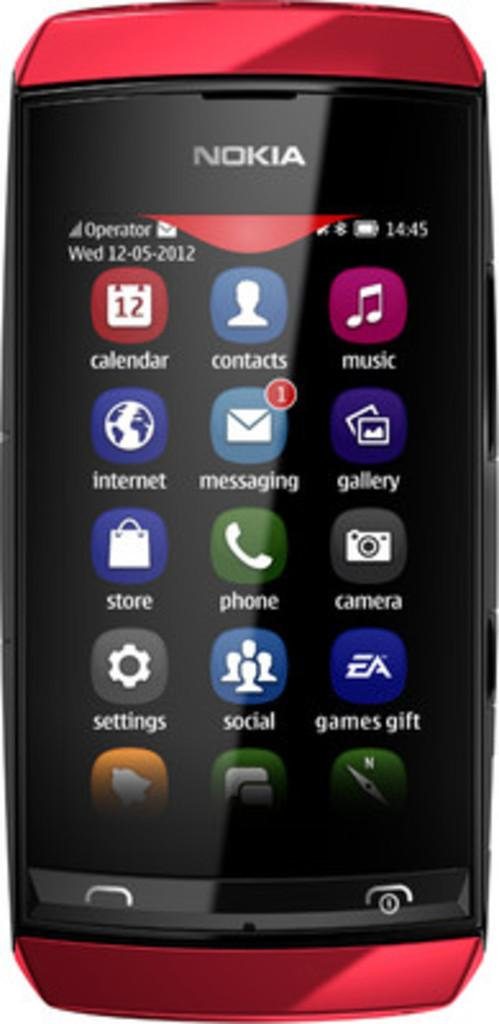<image>
Provide a brief description of the given image. A red Nokia cellphone is showing an apps screen. 